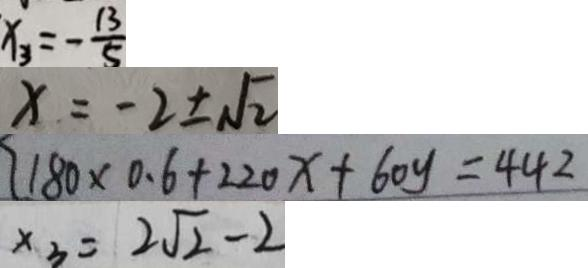Convert formula to latex. <formula><loc_0><loc_0><loc_500><loc_500>x _ { 3 } = - \frac { 1 3 } { 5 } 
 x = - 2 \pm \sqrt { 2 } 
 1 8 0 \times 0 . 6 + 2 2 0 x + 6 0 y = 4 4 2 
 x _ { 3 } = 2 \sqrt { 2 } - 2</formula> 